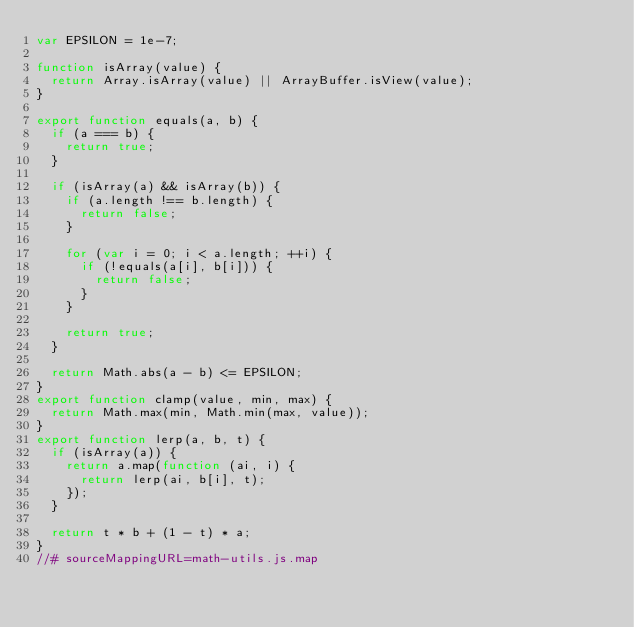<code> <loc_0><loc_0><loc_500><loc_500><_JavaScript_>var EPSILON = 1e-7;

function isArray(value) {
  return Array.isArray(value) || ArrayBuffer.isView(value);
}

export function equals(a, b) {
  if (a === b) {
    return true;
  }

  if (isArray(a) && isArray(b)) {
    if (a.length !== b.length) {
      return false;
    }

    for (var i = 0; i < a.length; ++i) {
      if (!equals(a[i], b[i])) {
        return false;
      }
    }

    return true;
  }

  return Math.abs(a - b) <= EPSILON;
}
export function clamp(value, min, max) {
  return Math.max(min, Math.min(max, value));
}
export function lerp(a, b, t) {
  if (isArray(a)) {
    return a.map(function (ai, i) {
      return lerp(ai, b[i], t);
    });
  }

  return t * b + (1 - t) * a;
}
//# sourceMappingURL=math-utils.js.map</code> 